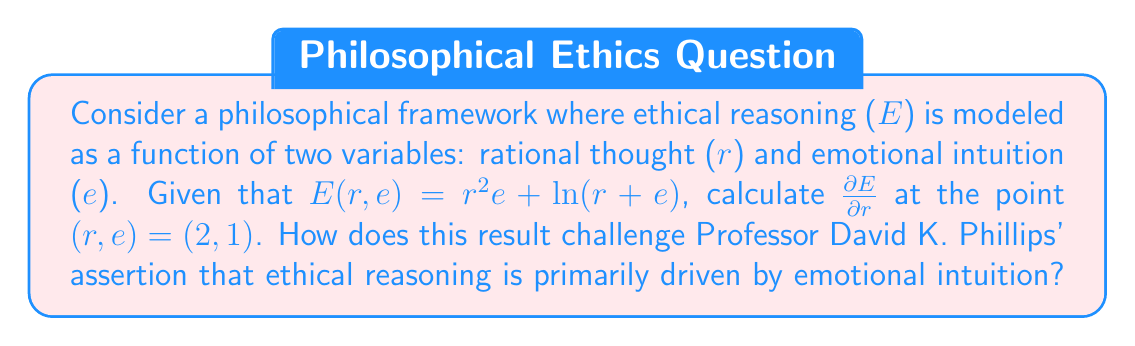Could you help me with this problem? To solve this problem, we need to find the partial derivative of E with respect to r and then evaluate it at the given point. This will show us how the rate of change of ethical reasoning changes with respect to rational thought, keeping emotional intuition constant.

1) First, let's find $\frac{\partial E}{\partial r}$:

   $$\frac{\partial E}{\partial r} = \frac{\partial}{\partial r}(r^2e + \ln(r+e))$$
   $$= 2re + \frac{1}{r+e}$$

2) Now, we evaluate this partial derivative at the point (r,e) = (2,1):

   $$\frac{\partial E}{\partial r}\bigg|_{(2,1)} = 2(2)(1) + \frac{1}{2+1}$$
   $$= 4 + \frac{1}{3}$$
   $$= \frac{12}{3} + \frac{1}{3} = \frac{13}{3}$$

3) This result shows that at the point (2,1), the rate of change of ethical reasoning with respect to rational thought is positive and significant ($\frac{13}{3} \approx 4.33$).

This challenges Professor David K. Phillips' theory by demonstrating that rational thought has a substantial impact on ethical reasoning. The large positive value indicates that increases in rational thought lead to significant increases in ethical reasoning, even when emotional intuition is held constant. This contradicts the notion that ethical reasoning is primarily driven by emotional intuition, as the model shows a strong dependence on the rational component.
Answer: $\frac{\partial E}{\partial r}\bigg|_{(2,1)} = \frac{13}{3}$ 